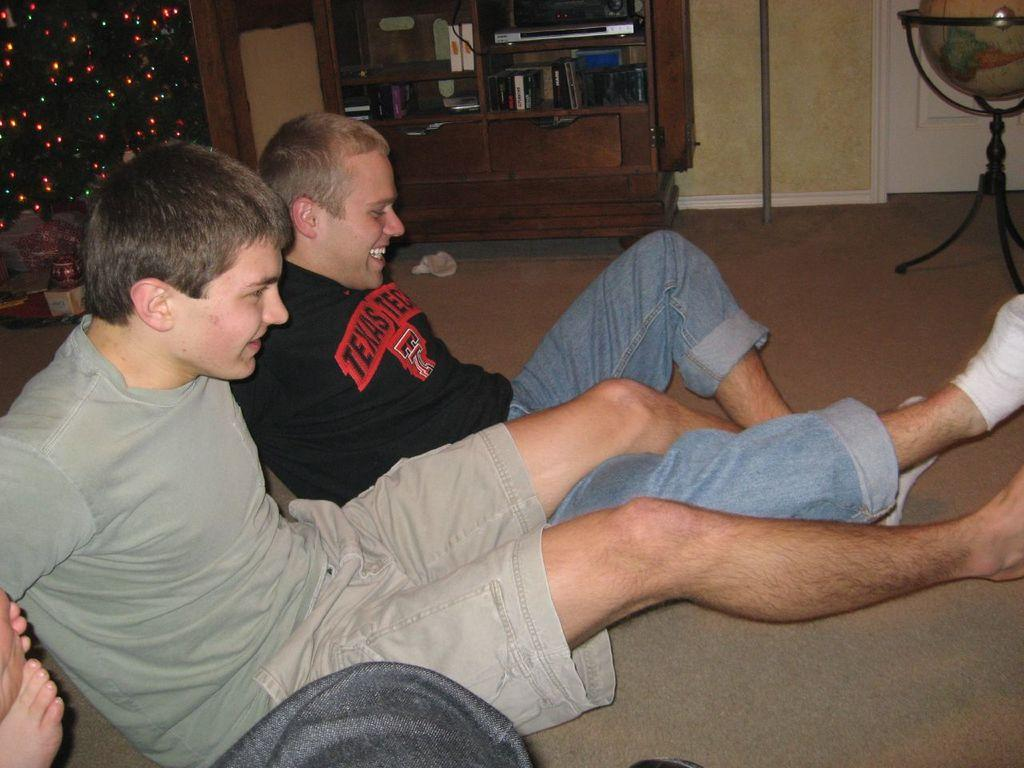<image>
Write a terse but informative summary of the picture. two people sitting with one wearing a Texas shirt 